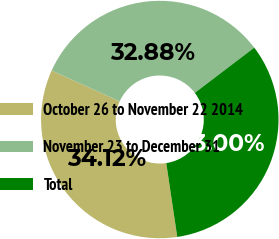Convert chart. <chart><loc_0><loc_0><loc_500><loc_500><pie_chart><fcel>October 26 to November 22 2014<fcel>November 23 to December 31<fcel>Total<nl><fcel>34.12%<fcel>32.88%<fcel>33.0%<nl></chart> 